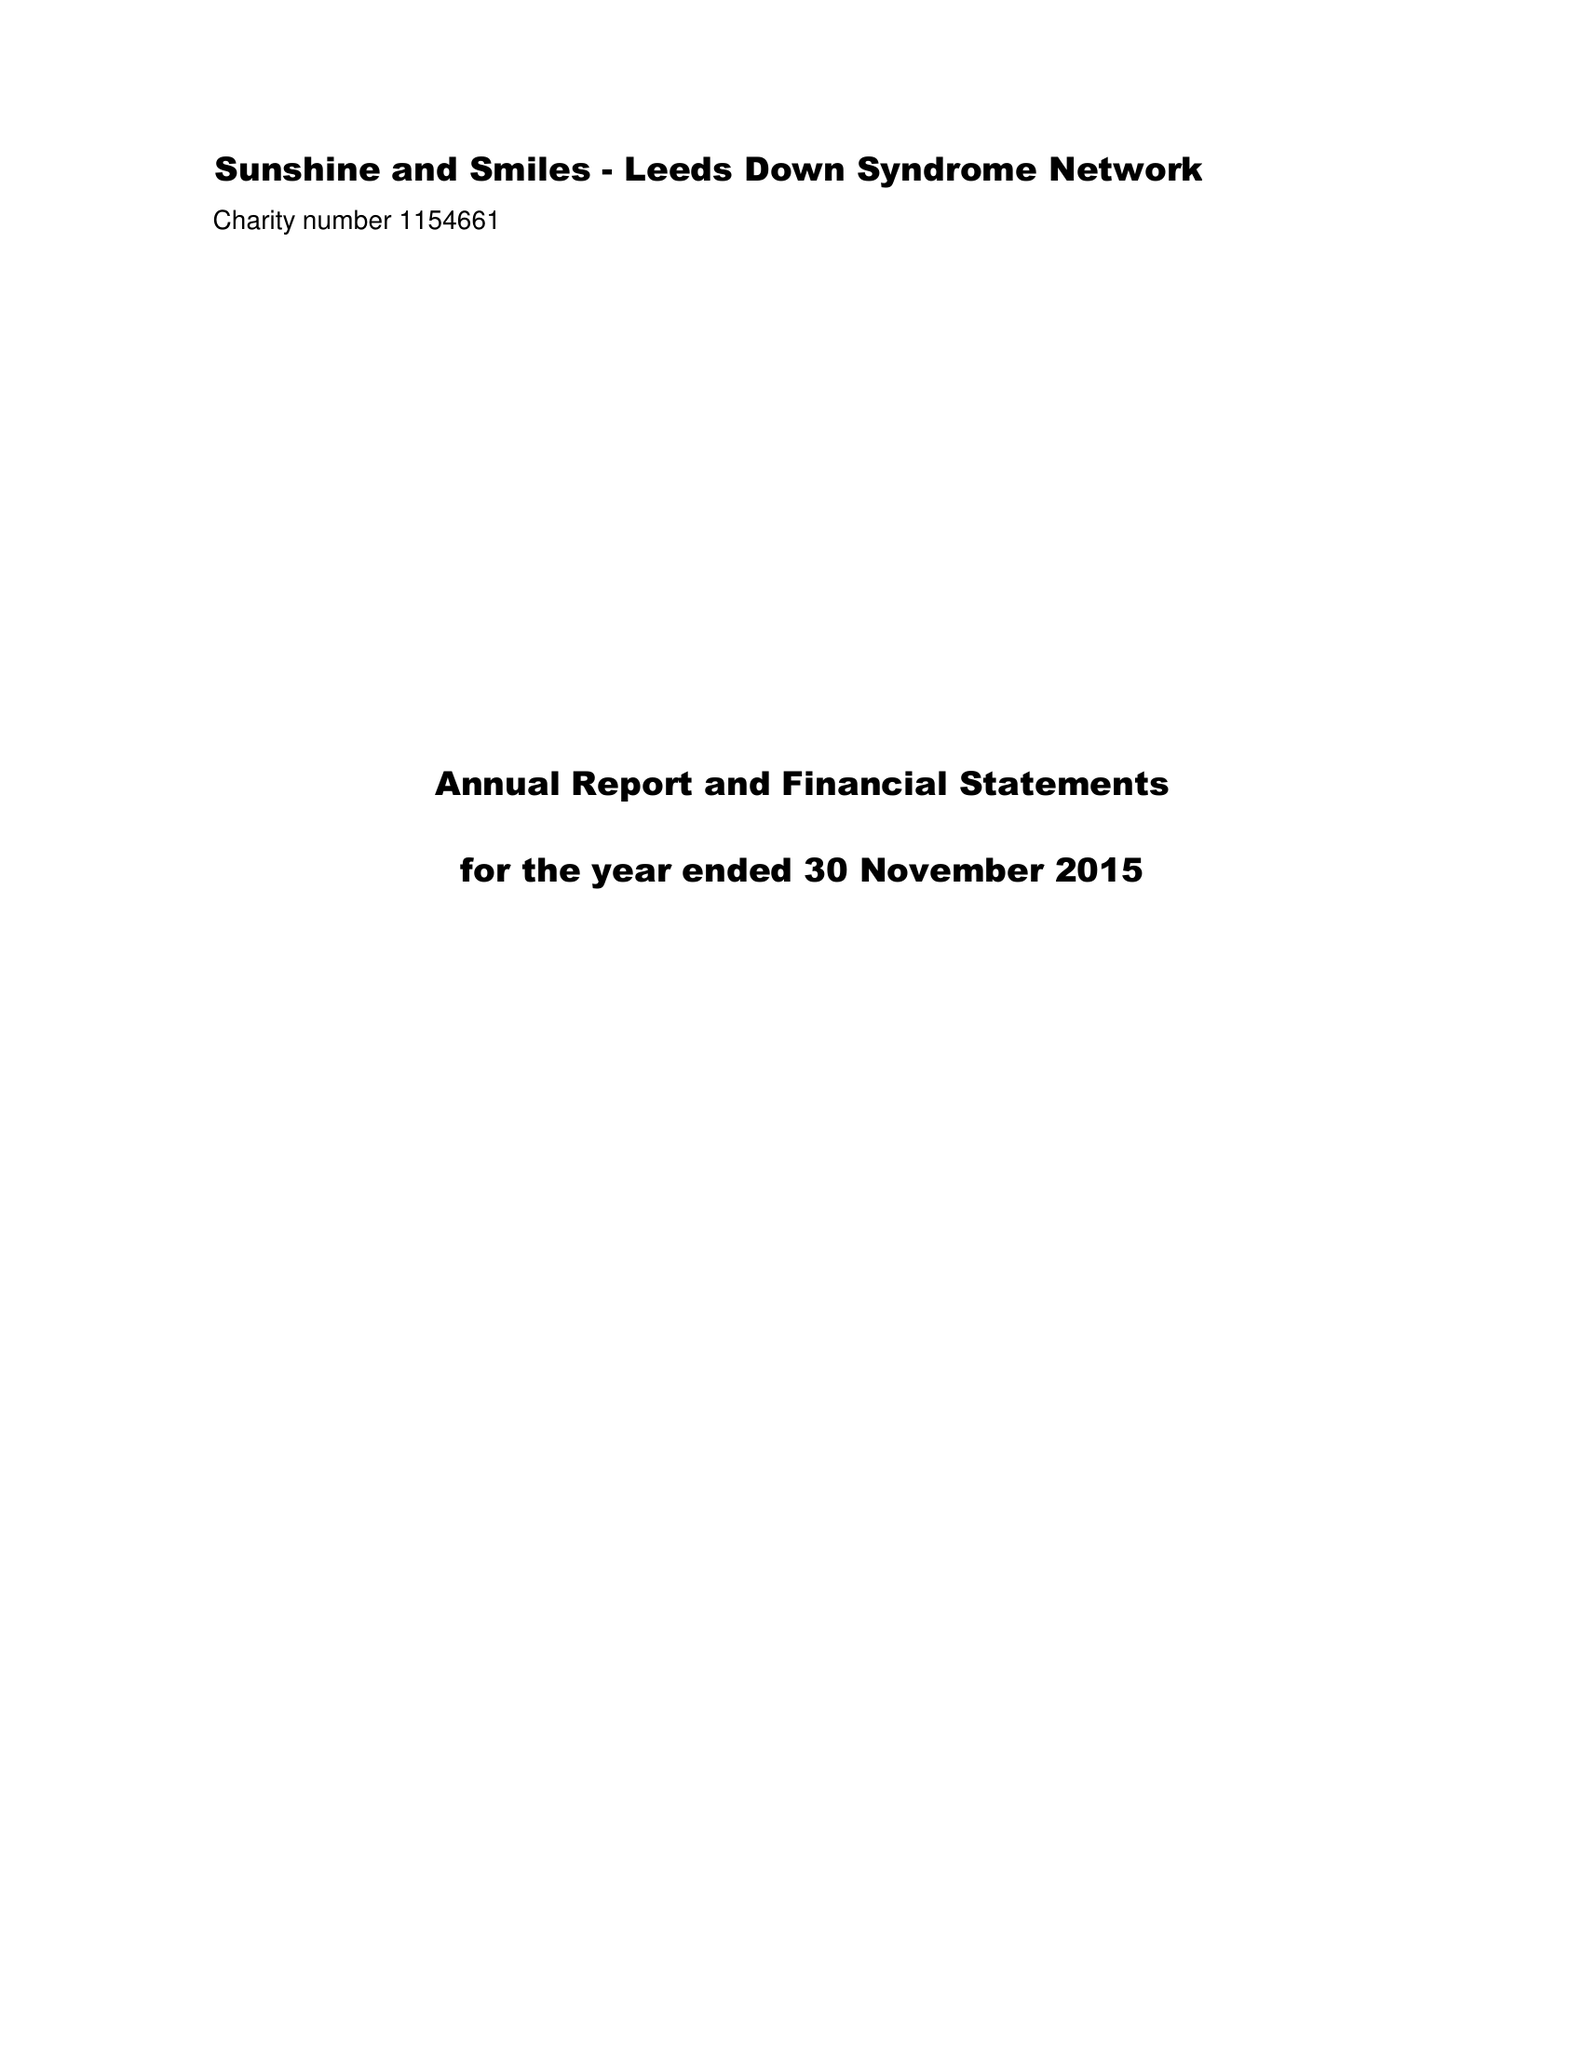What is the value for the address__post_town?
Answer the question using a single word or phrase. LEEDS 